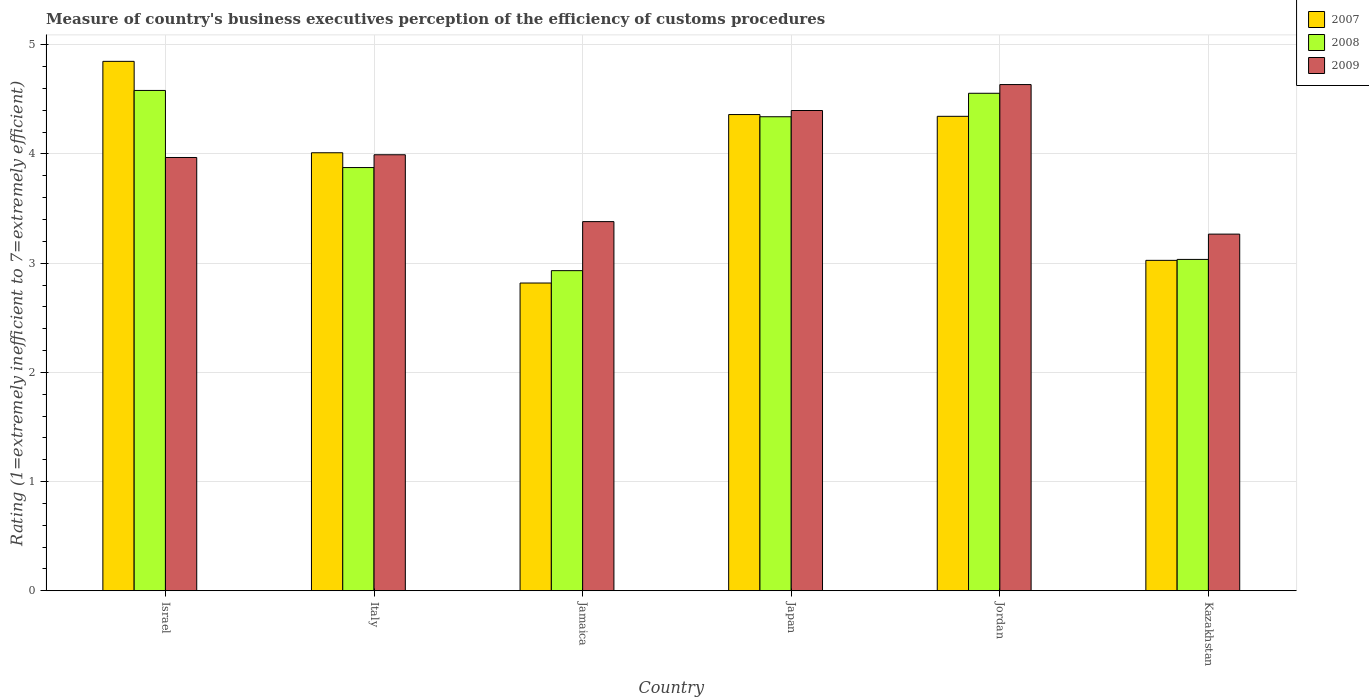How many different coloured bars are there?
Ensure brevity in your answer.  3. Are the number of bars on each tick of the X-axis equal?
Your answer should be compact. Yes. How many bars are there on the 4th tick from the left?
Ensure brevity in your answer.  3. How many bars are there on the 5th tick from the right?
Your answer should be compact. 3. In how many cases, is the number of bars for a given country not equal to the number of legend labels?
Your response must be concise. 0. What is the rating of the efficiency of customs procedure in 2009 in Jamaica?
Your answer should be very brief. 3.38. Across all countries, what is the maximum rating of the efficiency of customs procedure in 2008?
Your answer should be very brief. 4.58. Across all countries, what is the minimum rating of the efficiency of customs procedure in 2008?
Keep it short and to the point. 2.93. In which country was the rating of the efficiency of customs procedure in 2008 minimum?
Provide a succinct answer. Jamaica. What is the total rating of the efficiency of customs procedure in 2008 in the graph?
Provide a short and direct response. 23.32. What is the difference between the rating of the efficiency of customs procedure in 2007 in Japan and that in Kazakhstan?
Your answer should be very brief. 1.34. What is the difference between the rating of the efficiency of customs procedure in 2007 in Italy and the rating of the efficiency of customs procedure in 2008 in Kazakhstan?
Give a very brief answer. 0.98. What is the average rating of the efficiency of customs procedure in 2007 per country?
Your answer should be very brief. 3.9. What is the difference between the rating of the efficiency of customs procedure of/in 2008 and rating of the efficiency of customs procedure of/in 2007 in Italy?
Offer a terse response. -0.14. In how many countries, is the rating of the efficiency of customs procedure in 2009 greater than 4.6?
Provide a short and direct response. 1. What is the ratio of the rating of the efficiency of customs procedure in 2009 in Italy to that in Jamaica?
Offer a very short reply. 1.18. Is the rating of the efficiency of customs procedure in 2009 in Jordan less than that in Kazakhstan?
Your answer should be compact. No. What is the difference between the highest and the second highest rating of the efficiency of customs procedure in 2008?
Offer a very short reply. -0.24. What is the difference between the highest and the lowest rating of the efficiency of customs procedure in 2009?
Provide a short and direct response. 1.37. What does the 1st bar from the left in Jamaica represents?
Offer a terse response. 2007. What does the 3rd bar from the right in Jordan represents?
Provide a short and direct response. 2007. How many bars are there?
Offer a terse response. 18. Are all the bars in the graph horizontal?
Provide a short and direct response. No. How many countries are there in the graph?
Provide a short and direct response. 6. Does the graph contain any zero values?
Provide a short and direct response. No. Where does the legend appear in the graph?
Keep it short and to the point. Top right. What is the title of the graph?
Ensure brevity in your answer.  Measure of country's business executives perception of the efficiency of customs procedures. What is the label or title of the X-axis?
Your response must be concise. Country. What is the label or title of the Y-axis?
Your response must be concise. Rating (1=extremely inefficient to 7=extremely efficient). What is the Rating (1=extremely inefficient to 7=extremely efficient) in 2007 in Israel?
Provide a short and direct response. 4.85. What is the Rating (1=extremely inefficient to 7=extremely efficient) in 2008 in Israel?
Provide a succinct answer. 4.58. What is the Rating (1=extremely inefficient to 7=extremely efficient) of 2009 in Israel?
Ensure brevity in your answer.  3.97. What is the Rating (1=extremely inefficient to 7=extremely efficient) of 2007 in Italy?
Keep it short and to the point. 4.01. What is the Rating (1=extremely inefficient to 7=extremely efficient) of 2008 in Italy?
Offer a terse response. 3.88. What is the Rating (1=extremely inefficient to 7=extremely efficient) in 2009 in Italy?
Ensure brevity in your answer.  3.99. What is the Rating (1=extremely inefficient to 7=extremely efficient) of 2007 in Jamaica?
Ensure brevity in your answer.  2.82. What is the Rating (1=extremely inefficient to 7=extremely efficient) in 2008 in Jamaica?
Give a very brief answer. 2.93. What is the Rating (1=extremely inefficient to 7=extremely efficient) in 2009 in Jamaica?
Offer a very short reply. 3.38. What is the Rating (1=extremely inefficient to 7=extremely efficient) of 2007 in Japan?
Make the answer very short. 4.36. What is the Rating (1=extremely inefficient to 7=extremely efficient) of 2008 in Japan?
Give a very brief answer. 4.34. What is the Rating (1=extremely inefficient to 7=extremely efficient) in 2009 in Japan?
Ensure brevity in your answer.  4.4. What is the Rating (1=extremely inefficient to 7=extremely efficient) of 2007 in Jordan?
Provide a short and direct response. 4.35. What is the Rating (1=extremely inefficient to 7=extremely efficient) in 2008 in Jordan?
Provide a short and direct response. 4.56. What is the Rating (1=extremely inefficient to 7=extremely efficient) of 2009 in Jordan?
Offer a very short reply. 4.64. What is the Rating (1=extremely inefficient to 7=extremely efficient) of 2007 in Kazakhstan?
Keep it short and to the point. 3.03. What is the Rating (1=extremely inefficient to 7=extremely efficient) of 2008 in Kazakhstan?
Make the answer very short. 3.03. What is the Rating (1=extremely inefficient to 7=extremely efficient) in 2009 in Kazakhstan?
Make the answer very short. 3.27. Across all countries, what is the maximum Rating (1=extremely inefficient to 7=extremely efficient) in 2007?
Provide a short and direct response. 4.85. Across all countries, what is the maximum Rating (1=extremely inefficient to 7=extremely efficient) in 2008?
Keep it short and to the point. 4.58. Across all countries, what is the maximum Rating (1=extremely inefficient to 7=extremely efficient) of 2009?
Offer a terse response. 4.64. Across all countries, what is the minimum Rating (1=extremely inefficient to 7=extremely efficient) of 2007?
Your answer should be compact. 2.82. Across all countries, what is the minimum Rating (1=extremely inefficient to 7=extremely efficient) in 2008?
Offer a very short reply. 2.93. Across all countries, what is the minimum Rating (1=extremely inefficient to 7=extremely efficient) of 2009?
Provide a short and direct response. 3.27. What is the total Rating (1=extremely inefficient to 7=extremely efficient) in 2007 in the graph?
Provide a succinct answer. 23.41. What is the total Rating (1=extremely inefficient to 7=extremely efficient) in 2008 in the graph?
Offer a terse response. 23.32. What is the total Rating (1=extremely inefficient to 7=extremely efficient) of 2009 in the graph?
Your answer should be very brief. 23.64. What is the difference between the Rating (1=extremely inefficient to 7=extremely efficient) of 2007 in Israel and that in Italy?
Provide a short and direct response. 0.84. What is the difference between the Rating (1=extremely inefficient to 7=extremely efficient) of 2008 in Israel and that in Italy?
Your answer should be compact. 0.71. What is the difference between the Rating (1=extremely inefficient to 7=extremely efficient) of 2009 in Israel and that in Italy?
Offer a very short reply. -0.03. What is the difference between the Rating (1=extremely inefficient to 7=extremely efficient) in 2007 in Israel and that in Jamaica?
Provide a succinct answer. 2.03. What is the difference between the Rating (1=extremely inefficient to 7=extremely efficient) of 2008 in Israel and that in Jamaica?
Offer a very short reply. 1.65. What is the difference between the Rating (1=extremely inefficient to 7=extremely efficient) in 2009 in Israel and that in Jamaica?
Give a very brief answer. 0.59. What is the difference between the Rating (1=extremely inefficient to 7=extremely efficient) in 2007 in Israel and that in Japan?
Offer a very short reply. 0.49. What is the difference between the Rating (1=extremely inefficient to 7=extremely efficient) of 2008 in Israel and that in Japan?
Keep it short and to the point. 0.24. What is the difference between the Rating (1=extremely inefficient to 7=extremely efficient) in 2009 in Israel and that in Japan?
Make the answer very short. -0.43. What is the difference between the Rating (1=extremely inefficient to 7=extremely efficient) in 2007 in Israel and that in Jordan?
Your answer should be compact. 0.5. What is the difference between the Rating (1=extremely inefficient to 7=extremely efficient) of 2008 in Israel and that in Jordan?
Your response must be concise. 0.03. What is the difference between the Rating (1=extremely inefficient to 7=extremely efficient) of 2009 in Israel and that in Jordan?
Provide a short and direct response. -0.67. What is the difference between the Rating (1=extremely inefficient to 7=extremely efficient) in 2007 in Israel and that in Kazakhstan?
Give a very brief answer. 1.82. What is the difference between the Rating (1=extremely inefficient to 7=extremely efficient) of 2008 in Israel and that in Kazakhstan?
Provide a succinct answer. 1.55. What is the difference between the Rating (1=extremely inefficient to 7=extremely efficient) of 2009 in Israel and that in Kazakhstan?
Give a very brief answer. 0.7. What is the difference between the Rating (1=extremely inefficient to 7=extremely efficient) of 2007 in Italy and that in Jamaica?
Offer a terse response. 1.19. What is the difference between the Rating (1=extremely inefficient to 7=extremely efficient) in 2008 in Italy and that in Jamaica?
Offer a terse response. 0.94. What is the difference between the Rating (1=extremely inefficient to 7=extremely efficient) in 2009 in Italy and that in Jamaica?
Give a very brief answer. 0.61. What is the difference between the Rating (1=extremely inefficient to 7=extremely efficient) of 2007 in Italy and that in Japan?
Offer a very short reply. -0.35. What is the difference between the Rating (1=extremely inefficient to 7=extremely efficient) of 2008 in Italy and that in Japan?
Your answer should be compact. -0.47. What is the difference between the Rating (1=extremely inefficient to 7=extremely efficient) of 2009 in Italy and that in Japan?
Ensure brevity in your answer.  -0.41. What is the difference between the Rating (1=extremely inefficient to 7=extremely efficient) of 2007 in Italy and that in Jordan?
Keep it short and to the point. -0.33. What is the difference between the Rating (1=extremely inefficient to 7=extremely efficient) in 2008 in Italy and that in Jordan?
Ensure brevity in your answer.  -0.68. What is the difference between the Rating (1=extremely inefficient to 7=extremely efficient) in 2009 in Italy and that in Jordan?
Your answer should be very brief. -0.64. What is the difference between the Rating (1=extremely inefficient to 7=extremely efficient) in 2007 in Italy and that in Kazakhstan?
Make the answer very short. 0.99. What is the difference between the Rating (1=extremely inefficient to 7=extremely efficient) of 2008 in Italy and that in Kazakhstan?
Give a very brief answer. 0.84. What is the difference between the Rating (1=extremely inefficient to 7=extremely efficient) of 2009 in Italy and that in Kazakhstan?
Give a very brief answer. 0.73. What is the difference between the Rating (1=extremely inefficient to 7=extremely efficient) in 2007 in Jamaica and that in Japan?
Offer a very short reply. -1.54. What is the difference between the Rating (1=extremely inefficient to 7=extremely efficient) in 2008 in Jamaica and that in Japan?
Provide a short and direct response. -1.41. What is the difference between the Rating (1=extremely inefficient to 7=extremely efficient) in 2009 in Jamaica and that in Japan?
Provide a succinct answer. -1.02. What is the difference between the Rating (1=extremely inefficient to 7=extremely efficient) of 2007 in Jamaica and that in Jordan?
Ensure brevity in your answer.  -1.53. What is the difference between the Rating (1=extremely inefficient to 7=extremely efficient) in 2008 in Jamaica and that in Jordan?
Ensure brevity in your answer.  -1.62. What is the difference between the Rating (1=extremely inefficient to 7=extremely efficient) in 2009 in Jamaica and that in Jordan?
Your answer should be compact. -1.26. What is the difference between the Rating (1=extremely inefficient to 7=extremely efficient) in 2007 in Jamaica and that in Kazakhstan?
Keep it short and to the point. -0.21. What is the difference between the Rating (1=extremely inefficient to 7=extremely efficient) of 2008 in Jamaica and that in Kazakhstan?
Keep it short and to the point. -0.1. What is the difference between the Rating (1=extremely inefficient to 7=extremely efficient) of 2009 in Jamaica and that in Kazakhstan?
Provide a short and direct response. 0.11. What is the difference between the Rating (1=extremely inefficient to 7=extremely efficient) in 2007 in Japan and that in Jordan?
Your response must be concise. 0.02. What is the difference between the Rating (1=extremely inefficient to 7=extremely efficient) in 2008 in Japan and that in Jordan?
Offer a terse response. -0.21. What is the difference between the Rating (1=extremely inefficient to 7=extremely efficient) of 2009 in Japan and that in Jordan?
Ensure brevity in your answer.  -0.24. What is the difference between the Rating (1=extremely inefficient to 7=extremely efficient) of 2007 in Japan and that in Kazakhstan?
Ensure brevity in your answer.  1.34. What is the difference between the Rating (1=extremely inefficient to 7=extremely efficient) of 2008 in Japan and that in Kazakhstan?
Provide a short and direct response. 1.31. What is the difference between the Rating (1=extremely inefficient to 7=extremely efficient) of 2009 in Japan and that in Kazakhstan?
Offer a terse response. 1.13. What is the difference between the Rating (1=extremely inefficient to 7=extremely efficient) of 2007 in Jordan and that in Kazakhstan?
Your answer should be very brief. 1.32. What is the difference between the Rating (1=extremely inefficient to 7=extremely efficient) in 2008 in Jordan and that in Kazakhstan?
Keep it short and to the point. 1.52. What is the difference between the Rating (1=extremely inefficient to 7=extremely efficient) of 2009 in Jordan and that in Kazakhstan?
Ensure brevity in your answer.  1.37. What is the difference between the Rating (1=extremely inefficient to 7=extremely efficient) of 2007 in Israel and the Rating (1=extremely inefficient to 7=extremely efficient) of 2008 in Italy?
Your answer should be very brief. 0.97. What is the difference between the Rating (1=extremely inefficient to 7=extremely efficient) of 2007 in Israel and the Rating (1=extremely inefficient to 7=extremely efficient) of 2009 in Italy?
Your answer should be very brief. 0.86. What is the difference between the Rating (1=extremely inefficient to 7=extremely efficient) of 2008 in Israel and the Rating (1=extremely inefficient to 7=extremely efficient) of 2009 in Italy?
Provide a succinct answer. 0.59. What is the difference between the Rating (1=extremely inefficient to 7=extremely efficient) of 2007 in Israel and the Rating (1=extremely inefficient to 7=extremely efficient) of 2008 in Jamaica?
Your answer should be compact. 1.92. What is the difference between the Rating (1=extremely inefficient to 7=extremely efficient) in 2007 in Israel and the Rating (1=extremely inefficient to 7=extremely efficient) in 2009 in Jamaica?
Offer a very short reply. 1.47. What is the difference between the Rating (1=extremely inefficient to 7=extremely efficient) in 2008 in Israel and the Rating (1=extremely inefficient to 7=extremely efficient) in 2009 in Jamaica?
Keep it short and to the point. 1.2. What is the difference between the Rating (1=extremely inefficient to 7=extremely efficient) of 2007 in Israel and the Rating (1=extremely inefficient to 7=extremely efficient) of 2008 in Japan?
Provide a succinct answer. 0.51. What is the difference between the Rating (1=extremely inefficient to 7=extremely efficient) in 2007 in Israel and the Rating (1=extremely inefficient to 7=extremely efficient) in 2009 in Japan?
Provide a succinct answer. 0.45. What is the difference between the Rating (1=extremely inefficient to 7=extremely efficient) of 2008 in Israel and the Rating (1=extremely inefficient to 7=extremely efficient) of 2009 in Japan?
Your answer should be compact. 0.18. What is the difference between the Rating (1=extremely inefficient to 7=extremely efficient) in 2007 in Israel and the Rating (1=extremely inefficient to 7=extremely efficient) in 2008 in Jordan?
Your answer should be compact. 0.29. What is the difference between the Rating (1=extremely inefficient to 7=extremely efficient) in 2007 in Israel and the Rating (1=extremely inefficient to 7=extremely efficient) in 2009 in Jordan?
Provide a short and direct response. 0.21. What is the difference between the Rating (1=extremely inefficient to 7=extremely efficient) in 2008 in Israel and the Rating (1=extremely inefficient to 7=extremely efficient) in 2009 in Jordan?
Offer a terse response. -0.05. What is the difference between the Rating (1=extremely inefficient to 7=extremely efficient) in 2007 in Israel and the Rating (1=extremely inefficient to 7=extremely efficient) in 2008 in Kazakhstan?
Your answer should be very brief. 1.81. What is the difference between the Rating (1=extremely inefficient to 7=extremely efficient) of 2007 in Israel and the Rating (1=extremely inefficient to 7=extremely efficient) of 2009 in Kazakhstan?
Offer a terse response. 1.58. What is the difference between the Rating (1=extremely inefficient to 7=extremely efficient) in 2008 in Israel and the Rating (1=extremely inefficient to 7=extremely efficient) in 2009 in Kazakhstan?
Provide a succinct answer. 1.32. What is the difference between the Rating (1=extremely inefficient to 7=extremely efficient) in 2007 in Italy and the Rating (1=extremely inefficient to 7=extremely efficient) in 2008 in Jamaica?
Your answer should be very brief. 1.08. What is the difference between the Rating (1=extremely inefficient to 7=extremely efficient) of 2007 in Italy and the Rating (1=extremely inefficient to 7=extremely efficient) of 2009 in Jamaica?
Provide a succinct answer. 0.63. What is the difference between the Rating (1=extremely inefficient to 7=extremely efficient) in 2008 in Italy and the Rating (1=extremely inefficient to 7=extremely efficient) in 2009 in Jamaica?
Provide a short and direct response. 0.5. What is the difference between the Rating (1=extremely inefficient to 7=extremely efficient) of 2007 in Italy and the Rating (1=extremely inefficient to 7=extremely efficient) of 2008 in Japan?
Keep it short and to the point. -0.33. What is the difference between the Rating (1=extremely inefficient to 7=extremely efficient) in 2007 in Italy and the Rating (1=extremely inefficient to 7=extremely efficient) in 2009 in Japan?
Offer a terse response. -0.39. What is the difference between the Rating (1=extremely inefficient to 7=extremely efficient) in 2008 in Italy and the Rating (1=extremely inefficient to 7=extremely efficient) in 2009 in Japan?
Offer a very short reply. -0.52. What is the difference between the Rating (1=extremely inefficient to 7=extremely efficient) of 2007 in Italy and the Rating (1=extremely inefficient to 7=extremely efficient) of 2008 in Jordan?
Your response must be concise. -0.54. What is the difference between the Rating (1=extremely inefficient to 7=extremely efficient) of 2007 in Italy and the Rating (1=extremely inefficient to 7=extremely efficient) of 2009 in Jordan?
Provide a short and direct response. -0.62. What is the difference between the Rating (1=extremely inefficient to 7=extremely efficient) of 2008 in Italy and the Rating (1=extremely inefficient to 7=extremely efficient) of 2009 in Jordan?
Keep it short and to the point. -0.76. What is the difference between the Rating (1=extremely inefficient to 7=extremely efficient) in 2007 in Italy and the Rating (1=extremely inefficient to 7=extremely efficient) in 2008 in Kazakhstan?
Ensure brevity in your answer.  0.98. What is the difference between the Rating (1=extremely inefficient to 7=extremely efficient) of 2007 in Italy and the Rating (1=extremely inefficient to 7=extremely efficient) of 2009 in Kazakhstan?
Ensure brevity in your answer.  0.75. What is the difference between the Rating (1=extremely inefficient to 7=extremely efficient) of 2008 in Italy and the Rating (1=extremely inefficient to 7=extremely efficient) of 2009 in Kazakhstan?
Make the answer very short. 0.61. What is the difference between the Rating (1=extremely inefficient to 7=extremely efficient) of 2007 in Jamaica and the Rating (1=extremely inefficient to 7=extremely efficient) of 2008 in Japan?
Your answer should be compact. -1.52. What is the difference between the Rating (1=extremely inefficient to 7=extremely efficient) of 2007 in Jamaica and the Rating (1=extremely inefficient to 7=extremely efficient) of 2009 in Japan?
Provide a short and direct response. -1.58. What is the difference between the Rating (1=extremely inefficient to 7=extremely efficient) in 2008 in Jamaica and the Rating (1=extremely inefficient to 7=extremely efficient) in 2009 in Japan?
Offer a very short reply. -1.47. What is the difference between the Rating (1=extremely inefficient to 7=extremely efficient) of 2007 in Jamaica and the Rating (1=extremely inefficient to 7=extremely efficient) of 2008 in Jordan?
Your response must be concise. -1.74. What is the difference between the Rating (1=extremely inefficient to 7=extremely efficient) of 2007 in Jamaica and the Rating (1=extremely inefficient to 7=extremely efficient) of 2009 in Jordan?
Your answer should be compact. -1.82. What is the difference between the Rating (1=extremely inefficient to 7=extremely efficient) in 2008 in Jamaica and the Rating (1=extremely inefficient to 7=extremely efficient) in 2009 in Jordan?
Your response must be concise. -1.7. What is the difference between the Rating (1=extremely inefficient to 7=extremely efficient) in 2007 in Jamaica and the Rating (1=extremely inefficient to 7=extremely efficient) in 2008 in Kazakhstan?
Offer a very short reply. -0.22. What is the difference between the Rating (1=extremely inefficient to 7=extremely efficient) in 2007 in Jamaica and the Rating (1=extremely inefficient to 7=extremely efficient) in 2009 in Kazakhstan?
Provide a short and direct response. -0.45. What is the difference between the Rating (1=extremely inefficient to 7=extremely efficient) of 2008 in Jamaica and the Rating (1=extremely inefficient to 7=extremely efficient) of 2009 in Kazakhstan?
Provide a short and direct response. -0.33. What is the difference between the Rating (1=extremely inefficient to 7=extremely efficient) of 2007 in Japan and the Rating (1=extremely inefficient to 7=extremely efficient) of 2008 in Jordan?
Your answer should be compact. -0.2. What is the difference between the Rating (1=extremely inefficient to 7=extremely efficient) of 2007 in Japan and the Rating (1=extremely inefficient to 7=extremely efficient) of 2009 in Jordan?
Make the answer very short. -0.27. What is the difference between the Rating (1=extremely inefficient to 7=extremely efficient) in 2008 in Japan and the Rating (1=extremely inefficient to 7=extremely efficient) in 2009 in Jordan?
Offer a terse response. -0.29. What is the difference between the Rating (1=extremely inefficient to 7=extremely efficient) in 2007 in Japan and the Rating (1=extremely inefficient to 7=extremely efficient) in 2008 in Kazakhstan?
Provide a succinct answer. 1.33. What is the difference between the Rating (1=extremely inefficient to 7=extremely efficient) of 2007 in Japan and the Rating (1=extremely inefficient to 7=extremely efficient) of 2009 in Kazakhstan?
Offer a very short reply. 1.1. What is the difference between the Rating (1=extremely inefficient to 7=extremely efficient) of 2008 in Japan and the Rating (1=extremely inefficient to 7=extremely efficient) of 2009 in Kazakhstan?
Your response must be concise. 1.08. What is the difference between the Rating (1=extremely inefficient to 7=extremely efficient) of 2007 in Jordan and the Rating (1=extremely inefficient to 7=extremely efficient) of 2008 in Kazakhstan?
Your answer should be very brief. 1.31. What is the difference between the Rating (1=extremely inefficient to 7=extremely efficient) in 2007 in Jordan and the Rating (1=extremely inefficient to 7=extremely efficient) in 2009 in Kazakhstan?
Provide a succinct answer. 1.08. What is the difference between the Rating (1=extremely inefficient to 7=extremely efficient) of 2008 in Jordan and the Rating (1=extremely inefficient to 7=extremely efficient) of 2009 in Kazakhstan?
Offer a terse response. 1.29. What is the average Rating (1=extremely inefficient to 7=extremely efficient) of 2007 per country?
Give a very brief answer. 3.9. What is the average Rating (1=extremely inefficient to 7=extremely efficient) of 2008 per country?
Give a very brief answer. 3.89. What is the average Rating (1=extremely inefficient to 7=extremely efficient) of 2009 per country?
Provide a short and direct response. 3.94. What is the difference between the Rating (1=extremely inefficient to 7=extremely efficient) in 2007 and Rating (1=extremely inefficient to 7=extremely efficient) in 2008 in Israel?
Offer a very short reply. 0.27. What is the difference between the Rating (1=extremely inefficient to 7=extremely efficient) in 2007 and Rating (1=extremely inefficient to 7=extremely efficient) in 2009 in Israel?
Your answer should be compact. 0.88. What is the difference between the Rating (1=extremely inefficient to 7=extremely efficient) of 2008 and Rating (1=extremely inefficient to 7=extremely efficient) of 2009 in Israel?
Provide a succinct answer. 0.61. What is the difference between the Rating (1=extremely inefficient to 7=extremely efficient) in 2007 and Rating (1=extremely inefficient to 7=extremely efficient) in 2008 in Italy?
Ensure brevity in your answer.  0.14. What is the difference between the Rating (1=extremely inefficient to 7=extremely efficient) in 2007 and Rating (1=extremely inefficient to 7=extremely efficient) in 2009 in Italy?
Give a very brief answer. 0.02. What is the difference between the Rating (1=extremely inefficient to 7=extremely efficient) of 2008 and Rating (1=extremely inefficient to 7=extremely efficient) of 2009 in Italy?
Give a very brief answer. -0.12. What is the difference between the Rating (1=extremely inefficient to 7=extremely efficient) in 2007 and Rating (1=extremely inefficient to 7=extremely efficient) in 2008 in Jamaica?
Keep it short and to the point. -0.11. What is the difference between the Rating (1=extremely inefficient to 7=extremely efficient) of 2007 and Rating (1=extremely inefficient to 7=extremely efficient) of 2009 in Jamaica?
Provide a succinct answer. -0.56. What is the difference between the Rating (1=extremely inefficient to 7=extremely efficient) in 2008 and Rating (1=extremely inefficient to 7=extremely efficient) in 2009 in Jamaica?
Make the answer very short. -0.45. What is the difference between the Rating (1=extremely inefficient to 7=extremely efficient) of 2007 and Rating (1=extremely inefficient to 7=extremely efficient) of 2008 in Japan?
Keep it short and to the point. 0.02. What is the difference between the Rating (1=extremely inefficient to 7=extremely efficient) in 2007 and Rating (1=extremely inefficient to 7=extremely efficient) in 2009 in Japan?
Give a very brief answer. -0.04. What is the difference between the Rating (1=extremely inefficient to 7=extremely efficient) of 2008 and Rating (1=extremely inefficient to 7=extremely efficient) of 2009 in Japan?
Offer a very short reply. -0.06. What is the difference between the Rating (1=extremely inefficient to 7=extremely efficient) of 2007 and Rating (1=extremely inefficient to 7=extremely efficient) of 2008 in Jordan?
Offer a terse response. -0.21. What is the difference between the Rating (1=extremely inefficient to 7=extremely efficient) in 2007 and Rating (1=extremely inefficient to 7=extremely efficient) in 2009 in Jordan?
Give a very brief answer. -0.29. What is the difference between the Rating (1=extremely inefficient to 7=extremely efficient) in 2008 and Rating (1=extremely inefficient to 7=extremely efficient) in 2009 in Jordan?
Keep it short and to the point. -0.08. What is the difference between the Rating (1=extremely inefficient to 7=extremely efficient) in 2007 and Rating (1=extremely inefficient to 7=extremely efficient) in 2008 in Kazakhstan?
Give a very brief answer. -0.01. What is the difference between the Rating (1=extremely inefficient to 7=extremely efficient) of 2007 and Rating (1=extremely inefficient to 7=extremely efficient) of 2009 in Kazakhstan?
Offer a very short reply. -0.24. What is the difference between the Rating (1=extremely inefficient to 7=extremely efficient) in 2008 and Rating (1=extremely inefficient to 7=extremely efficient) in 2009 in Kazakhstan?
Your answer should be very brief. -0.23. What is the ratio of the Rating (1=extremely inefficient to 7=extremely efficient) of 2007 in Israel to that in Italy?
Provide a succinct answer. 1.21. What is the ratio of the Rating (1=extremely inefficient to 7=extremely efficient) in 2008 in Israel to that in Italy?
Make the answer very short. 1.18. What is the ratio of the Rating (1=extremely inefficient to 7=extremely efficient) of 2007 in Israel to that in Jamaica?
Your answer should be compact. 1.72. What is the ratio of the Rating (1=extremely inefficient to 7=extremely efficient) in 2008 in Israel to that in Jamaica?
Make the answer very short. 1.56. What is the ratio of the Rating (1=extremely inefficient to 7=extremely efficient) of 2009 in Israel to that in Jamaica?
Provide a succinct answer. 1.17. What is the ratio of the Rating (1=extremely inefficient to 7=extremely efficient) of 2007 in Israel to that in Japan?
Your answer should be compact. 1.11. What is the ratio of the Rating (1=extremely inefficient to 7=extremely efficient) of 2008 in Israel to that in Japan?
Your answer should be compact. 1.06. What is the ratio of the Rating (1=extremely inefficient to 7=extremely efficient) in 2009 in Israel to that in Japan?
Your response must be concise. 0.9. What is the ratio of the Rating (1=extremely inefficient to 7=extremely efficient) in 2007 in Israel to that in Jordan?
Provide a short and direct response. 1.12. What is the ratio of the Rating (1=extremely inefficient to 7=extremely efficient) in 2009 in Israel to that in Jordan?
Provide a short and direct response. 0.86. What is the ratio of the Rating (1=extremely inefficient to 7=extremely efficient) in 2007 in Israel to that in Kazakhstan?
Offer a terse response. 1.6. What is the ratio of the Rating (1=extremely inefficient to 7=extremely efficient) in 2008 in Israel to that in Kazakhstan?
Make the answer very short. 1.51. What is the ratio of the Rating (1=extremely inefficient to 7=extremely efficient) in 2009 in Israel to that in Kazakhstan?
Ensure brevity in your answer.  1.21. What is the ratio of the Rating (1=extremely inefficient to 7=extremely efficient) of 2007 in Italy to that in Jamaica?
Provide a short and direct response. 1.42. What is the ratio of the Rating (1=extremely inefficient to 7=extremely efficient) in 2008 in Italy to that in Jamaica?
Give a very brief answer. 1.32. What is the ratio of the Rating (1=extremely inefficient to 7=extremely efficient) in 2009 in Italy to that in Jamaica?
Ensure brevity in your answer.  1.18. What is the ratio of the Rating (1=extremely inefficient to 7=extremely efficient) of 2007 in Italy to that in Japan?
Make the answer very short. 0.92. What is the ratio of the Rating (1=extremely inefficient to 7=extremely efficient) in 2008 in Italy to that in Japan?
Give a very brief answer. 0.89. What is the ratio of the Rating (1=extremely inefficient to 7=extremely efficient) in 2009 in Italy to that in Japan?
Provide a short and direct response. 0.91. What is the ratio of the Rating (1=extremely inefficient to 7=extremely efficient) of 2007 in Italy to that in Jordan?
Your answer should be compact. 0.92. What is the ratio of the Rating (1=extremely inefficient to 7=extremely efficient) in 2008 in Italy to that in Jordan?
Your response must be concise. 0.85. What is the ratio of the Rating (1=extremely inefficient to 7=extremely efficient) of 2009 in Italy to that in Jordan?
Offer a very short reply. 0.86. What is the ratio of the Rating (1=extremely inefficient to 7=extremely efficient) of 2007 in Italy to that in Kazakhstan?
Give a very brief answer. 1.33. What is the ratio of the Rating (1=extremely inefficient to 7=extremely efficient) of 2008 in Italy to that in Kazakhstan?
Offer a terse response. 1.28. What is the ratio of the Rating (1=extremely inefficient to 7=extremely efficient) of 2009 in Italy to that in Kazakhstan?
Your answer should be compact. 1.22. What is the ratio of the Rating (1=extremely inefficient to 7=extremely efficient) in 2007 in Jamaica to that in Japan?
Ensure brevity in your answer.  0.65. What is the ratio of the Rating (1=extremely inefficient to 7=extremely efficient) in 2008 in Jamaica to that in Japan?
Offer a terse response. 0.68. What is the ratio of the Rating (1=extremely inefficient to 7=extremely efficient) of 2009 in Jamaica to that in Japan?
Ensure brevity in your answer.  0.77. What is the ratio of the Rating (1=extremely inefficient to 7=extremely efficient) in 2007 in Jamaica to that in Jordan?
Provide a short and direct response. 0.65. What is the ratio of the Rating (1=extremely inefficient to 7=extremely efficient) in 2008 in Jamaica to that in Jordan?
Your answer should be compact. 0.64. What is the ratio of the Rating (1=extremely inefficient to 7=extremely efficient) of 2009 in Jamaica to that in Jordan?
Your answer should be very brief. 0.73. What is the ratio of the Rating (1=extremely inefficient to 7=extremely efficient) of 2007 in Jamaica to that in Kazakhstan?
Give a very brief answer. 0.93. What is the ratio of the Rating (1=extremely inefficient to 7=extremely efficient) in 2008 in Jamaica to that in Kazakhstan?
Provide a short and direct response. 0.97. What is the ratio of the Rating (1=extremely inefficient to 7=extremely efficient) in 2009 in Jamaica to that in Kazakhstan?
Make the answer very short. 1.04. What is the ratio of the Rating (1=extremely inefficient to 7=extremely efficient) in 2007 in Japan to that in Jordan?
Your answer should be compact. 1. What is the ratio of the Rating (1=extremely inefficient to 7=extremely efficient) of 2008 in Japan to that in Jordan?
Make the answer very short. 0.95. What is the ratio of the Rating (1=extremely inefficient to 7=extremely efficient) of 2009 in Japan to that in Jordan?
Offer a very short reply. 0.95. What is the ratio of the Rating (1=extremely inefficient to 7=extremely efficient) of 2007 in Japan to that in Kazakhstan?
Your answer should be very brief. 1.44. What is the ratio of the Rating (1=extremely inefficient to 7=extremely efficient) of 2008 in Japan to that in Kazakhstan?
Keep it short and to the point. 1.43. What is the ratio of the Rating (1=extremely inefficient to 7=extremely efficient) of 2009 in Japan to that in Kazakhstan?
Your response must be concise. 1.35. What is the ratio of the Rating (1=extremely inefficient to 7=extremely efficient) in 2007 in Jordan to that in Kazakhstan?
Give a very brief answer. 1.44. What is the ratio of the Rating (1=extremely inefficient to 7=extremely efficient) of 2008 in Jordan to that in Kazakhstan?
Ensure brevity in your answer.  1.5. What is the ratio of the Rating (1=extremely inefficient to 7=extremely efficient) in 2009 in Jordan to that in Kazakhstan?
Make the answer very short. 1.42. What is the difference between the highest and the second highest Rating (1=extremely inefficient to 7=extremely efficient) of 2007?
Give a very brief answer. 0.49. What is the difference between the highest and the second highest Rating (1=extremely inefficient to 7=extremely efficient) in 2008?
Your answer should be compact. 0.03. What is the difference between the highest and the second highest Rating (1=extremely inefficient to 7=extremely efficient) of 2009?
Your answer should be compact. 0.24. What is the difference between the highest and the lowest Rating (1=extremely inefficient to 7=extremely efficient) of 2007?
Give a very brief answer. 2.03. What is the difference between the highest and the lowest Rating (1=extremely inefficient to 7=extremely efficient) in 2008?
Provide a short and direct response. 1.65. What is the difference between the highest and the lowest Rating (1=extremely inefficient to 7=extremely efficient) of 2009?
Make the answer very short. 1.37. 